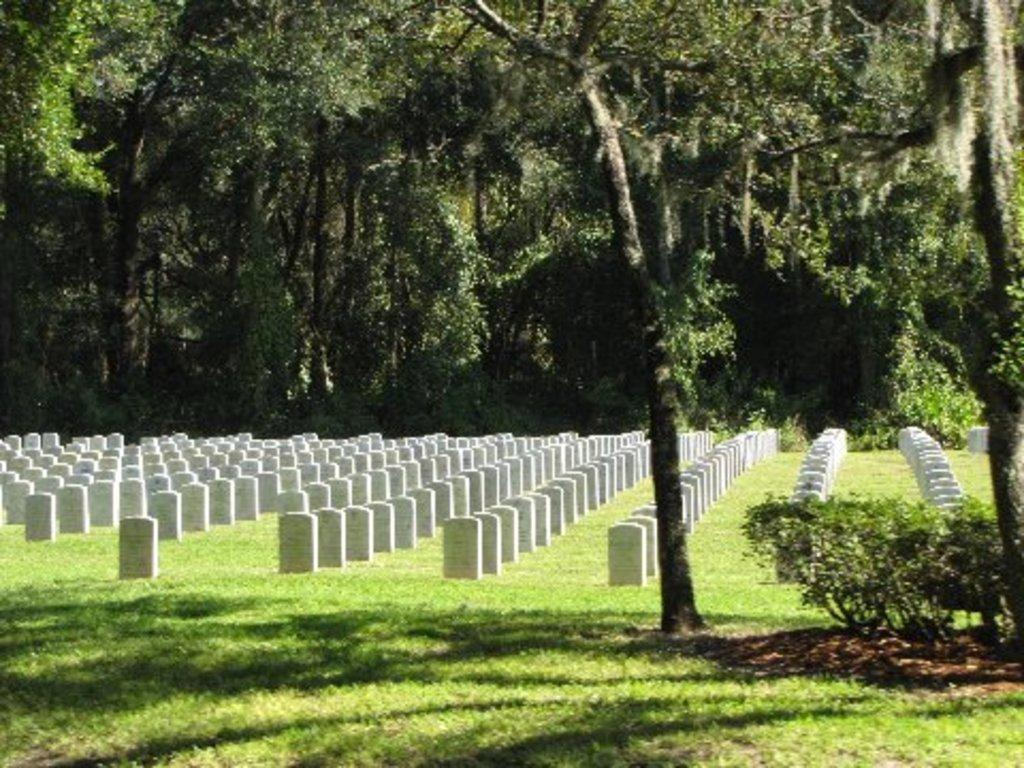What is the main subject located in the middle of the image? There is a graveyard in the middle of the image. What can be seen in the background of the image? There are many trees in the background of the image. What type of zipper can be seen on the trees in the image? There are no zippers present on the trees in the image. What type of arch is visible in the graveyard in the image? There is no specific arch mentioned or visible in the image; it only shows a graveyard with trees in the background. 